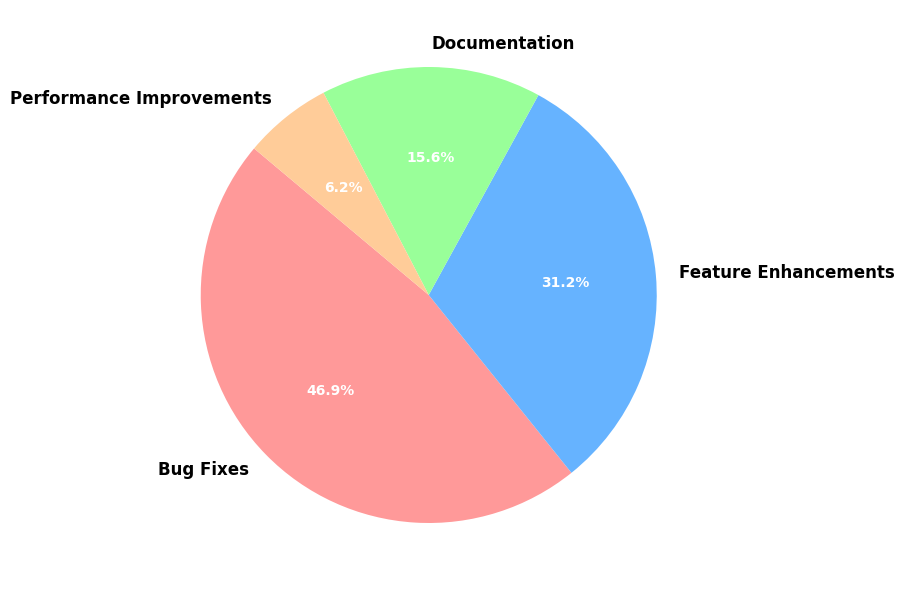Which category has the highest count? The category with the highest count can be identified by looking at the largest section of the pie chart. "Bug Fixes" occupies the most significant area, and its label shows the highest percentage.
Answer: Bug Fixes Which category represents 25% of the contributions? The category representing 25% of the contributions can be seen directly on the pie chart. "Documentation" shows 16.7%, "Feature Enhancements" shows 33.3%, and "Performance Improvements" shows 6.7%. Therefore, "Documentation" at 25%.
Answer: Feature Enhancements By how much does the number of Bug Fixes exceed Feature Enhancements? To find the difference, subtract the count of Feature Enhancements from the count of Bug Fixes. The count for Bug Fixes is 150, and Feature Enhancements is 100. Thus, 150 - 100 = 50.
Answer: 50 What percentage of contributions are Documentation and Performance Improvements combined? Sum the count of Documentation (50) and Performance Improvements (20). The total is 50 + 20 = 70. Calculate the percentage: (70/320) * 100 = 21.9%.
Answer: 21.9% Which section is the smallest in size? The smallest section of the pie chart can be identified by looking at the least occupied area. "Performance Improvements" is the smallest and has the least count.
Answer: Performance Improvements What is the ratio of Bug Fixes to Performance Improvements? The ratio of Bug Fixes to Performance Improvements can be calculated by dividing the count of Bug Fixes (150) by the count of Performance Improvements (20). Thus, the ratio is 150:20 or simplifying it, 7.5:1.
Answer: 7.5:1 Is the number of Documentation contributions greater than half of the number of Feature Enhancements? Compare the count of Documentation (50) to half the count of Feature Enhancements (100/2 = 50). 50 is equal to 50.
Answer: No What are the total contributions displayed in the pie chart? The total contributions are the sum of counts across all categories: Bug Fixes (150) + Feature Enhancements (100) + Documentation (50) + Performance Improvements (20) = 320.
Answer: 320 What is the average number of contributions per category? Calculate the average by dividing the total number of contributions (320) by the number of categories (4). So, 320 / 4 = 80.
Answer: 80 Which categories together make up more than 80% of the contributions? To find the categories combined making up more than 80%, sum their percentages until exceeding 80%. Bug Fixes (46.9%) + Feature Enhancements (31.3%) = 78.2%, adding Documentation (15.6%) gives over 90%. Thus, Bug Fixes, Feature Enhancements, and Documentation.
Answer: Bug Fixes and Feature Enhancements 